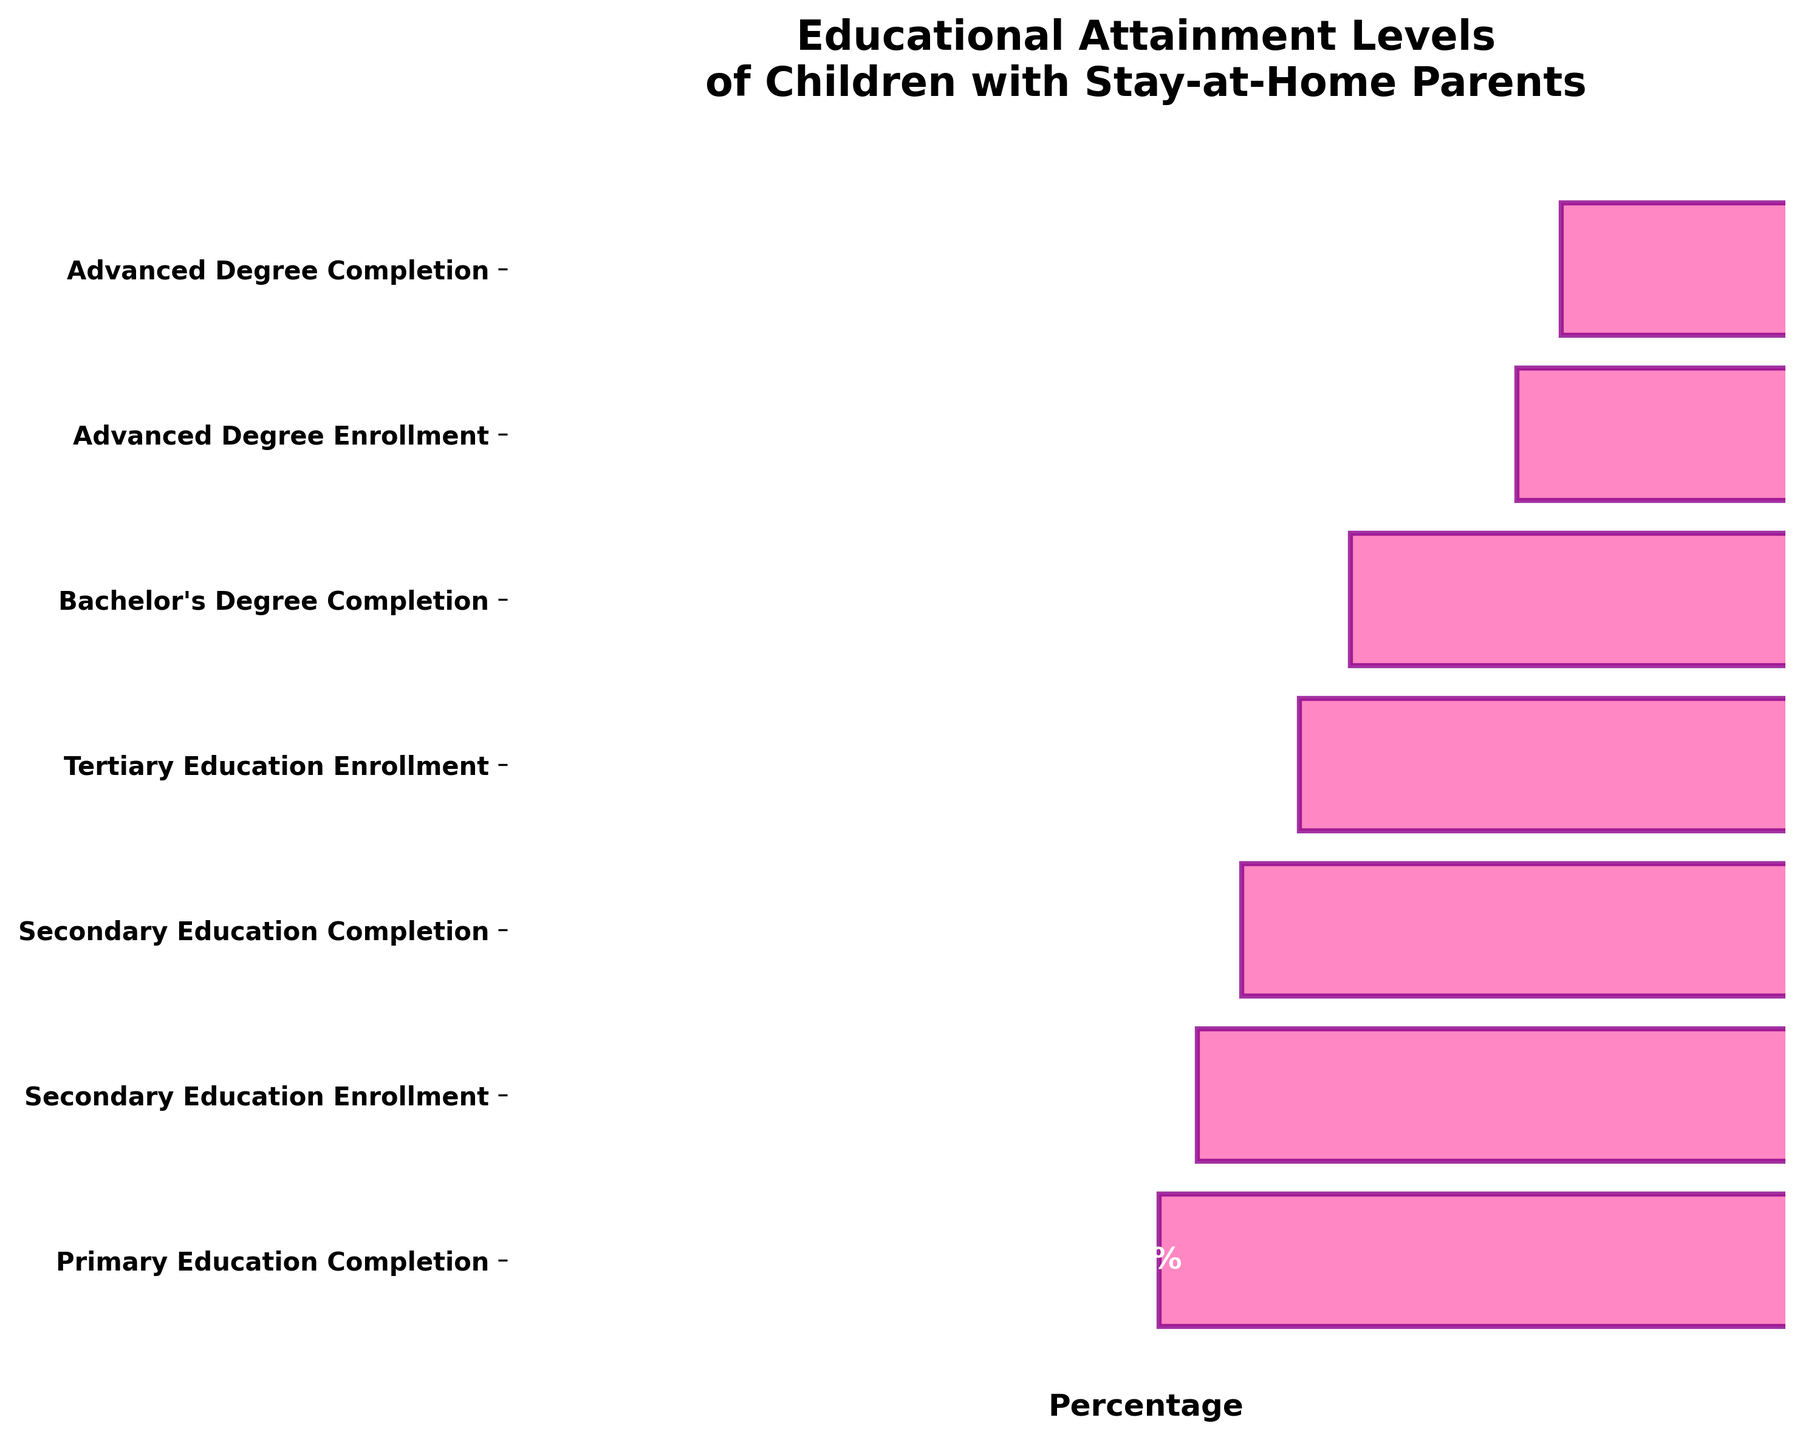What is the title of the funnel chart? The title of the chart is provided at the top. It states, "Educational Attainment Levels of Children with Stay-at-Home Parents".
Answer: Educational Attainment Levels of Children with Stay-at-Home Parents Which educational stage has the highest completion percentage? By looking at the percentages listed next to each stage, the stage with the highest completion percentage is "Primary Education Completion" at 98%.
Answer: Primary Education Completion How many stages are shown in this funnel chart? By counting the total number of bars or y-axis labels in the chart, there are 7 stages depicted.
Answer: 7 What is the difference between the completion percentages of Secondary Education and Tertiary Education? The percentages are 85% for Secondary Education Completion and 68% for Bachelor's Degree Completion. The difference is calculated as 85 - 68 = 17.
Answer: 17% What percentage of children enroll in tertiary education? From the chart, the percentage listed for "Tertiary Education Enrollment" is 76%.
Answer: 76% Which educational stage has the lowest enrollment percentage? By examining the "Enrollment" labels, the "Advanced Degree Enrollment" has the lowest percentage at 42%.
Answer: Advanced Degree Enrollment Is there a stage where the enrollment percentage is higher than the completion percentage of the previous stage? Comparing enrollment and completion percentages, Tertiary Education Enrollment (76%) is lower than the Secondary Education Completion (85%), so there is no stage where enrollment is higher.
Answer: No What trend can be observed as students move from primary to advanced education? The trend shows a decreasing percentage in both enrollment and completion rates at each successive educational stage.
Answer: Decreasing trend Which two stages have the closest percentages? "Bachelor's Degree Completion" at 68% and "Advanced Degree Enrollment" at 42% have a difference of 26 percentage points, so they might seem closer, but they are not close enough. Instead, "Secondary Education Enrollment" at 92% and "Secondary Education Completion" at 85% have the closest difference of 7 percentage points.
Answer: Secondary Education Enrollment and Secondary Education Completion How much lower is the Advanced Degree Completion percentage compared to the Primary Education Completion percentage? The Primary Education Completion is 98%, and the Advanced Degree Completion is 35%. The difference is 98 - 35 = 63 percentage points.
Answer: 63 